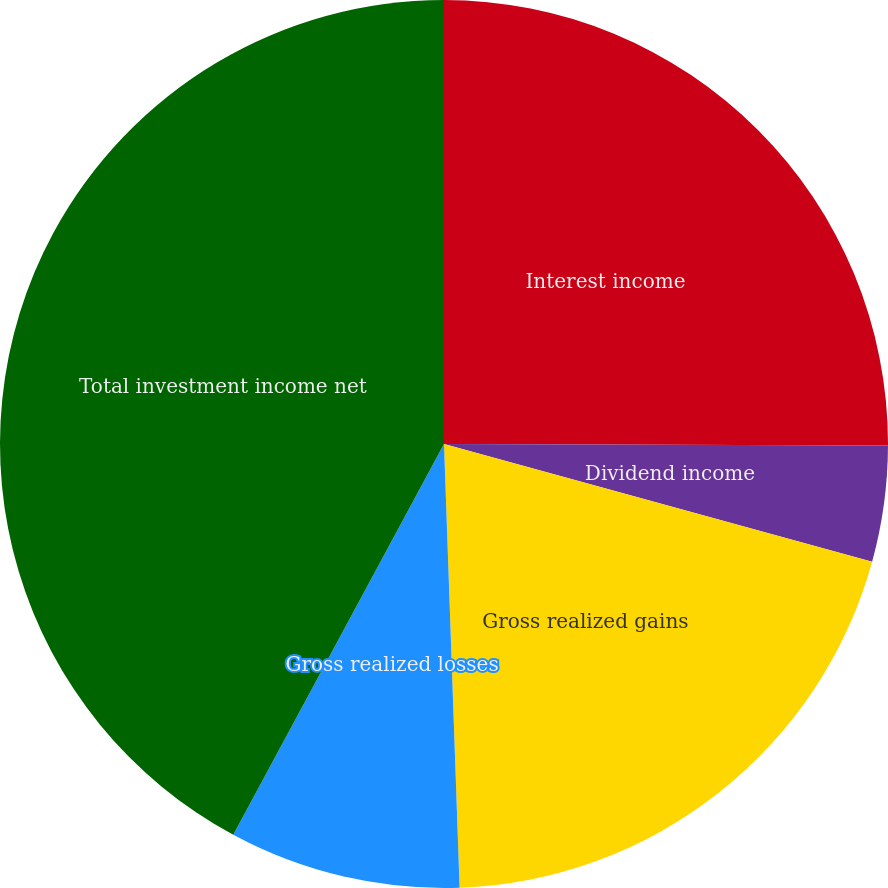<chart> <loc_0><loc_0><loc_500><loc_500><pie_chart><fcel>Interest income<fcel>Dividend income<fcel>Gross realized gains<fcel>Gross realized losses<fcel>Realized gains (losses) net<fcel>Total investment income net<nl><fcel>25.05%<fcel>4.22%<fcel>20.17%<fcel>8.43%<fcel>0.0%<fcel>42.13%<nl></chart> 